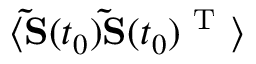<formula> <loc_0><loc_0><loc_500><loc_500>\langle \widetilde { S } ( t _ { 0 } ) \widetilde { S } ( t _ { 0 } ) ^ { T } \rangle</formula> 